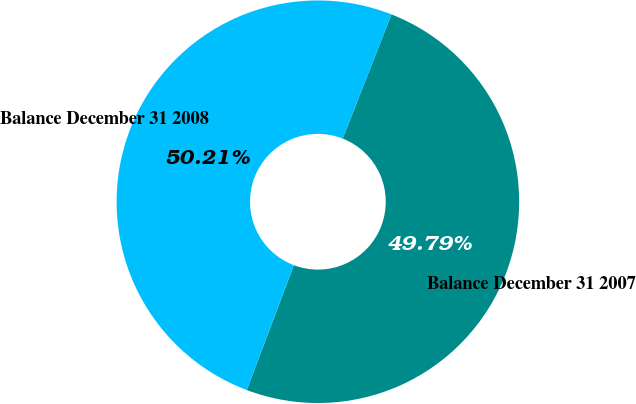<chart> <loc_0><loc_0><loc_500><loc_500><pie_chart><fcel>Balance December 31 2007<fcel>Balance December 31 2008<nl><fcel>49.79%<fcel>50.21%<nl></chart> 